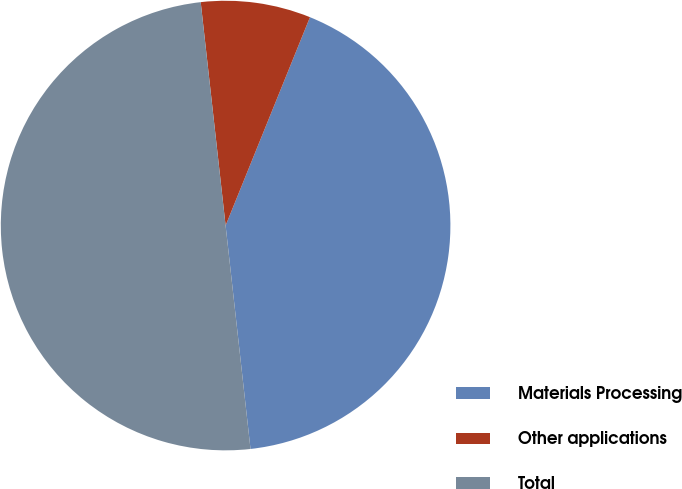<chart> <loc_0><loc_0><loc_500><loc_500><pie_chart><fcel>Materials Processing<fcel>Other applications<fcel>Total<nl><fcel>42.11%<fcel>7.89%<fcel>50.0%<nl></chart> 